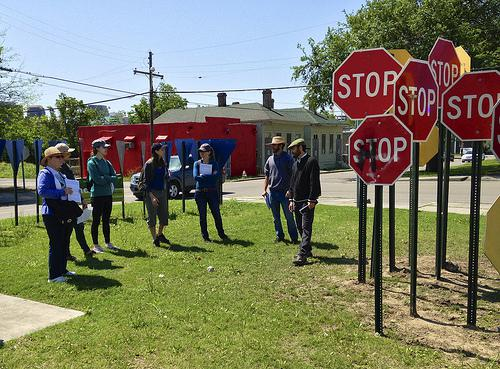Question: what shape are the red signs?
Choices:
A. Hexagonal.
B. Square.
C. Circular.
D. Octagonal.
Answer with the letter. Answer: D Question: what do these red signs say?
Choices:
A. Go.
B. Yield.
C. Stop.
D. Proceed with caution.
Answer with the letter. Answer: C Question: how many signs are visible?
Choices:
A. Two.
B. Five.
C. Four.
D. Three.
Answer with the letter. Answer: B Question: where are the people standing?
Choices:
A. In the river.
B. In the street.
C. In the grass.
D. In the corn fields.
Answer with the letter. Answer: C Question: what are all the people wearing on their heads?
Choices:
A. Tiaras.
B. Hats.
C. Bandannas.
D. Newspapers.
Answer with the letter. Answer: B Question: what are the stop signs attached to?
Choices:
A. Walls.
B. Garage door.
C. Wires.
D. Posts.
Answer with the letter. Answer: D Question: what does the weather look like?
Choices:
A. Rainy.
B. Snowy.
C. Windy.
D. Sunny.
Answer with the letter. Answer: D 